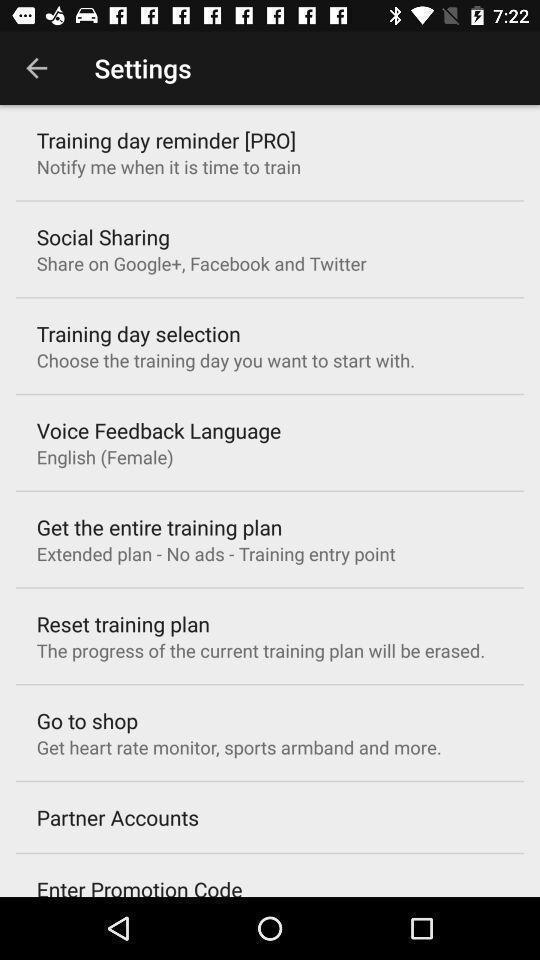What is the overall content of this screenshot? Settings tab in the mobile with different options. 